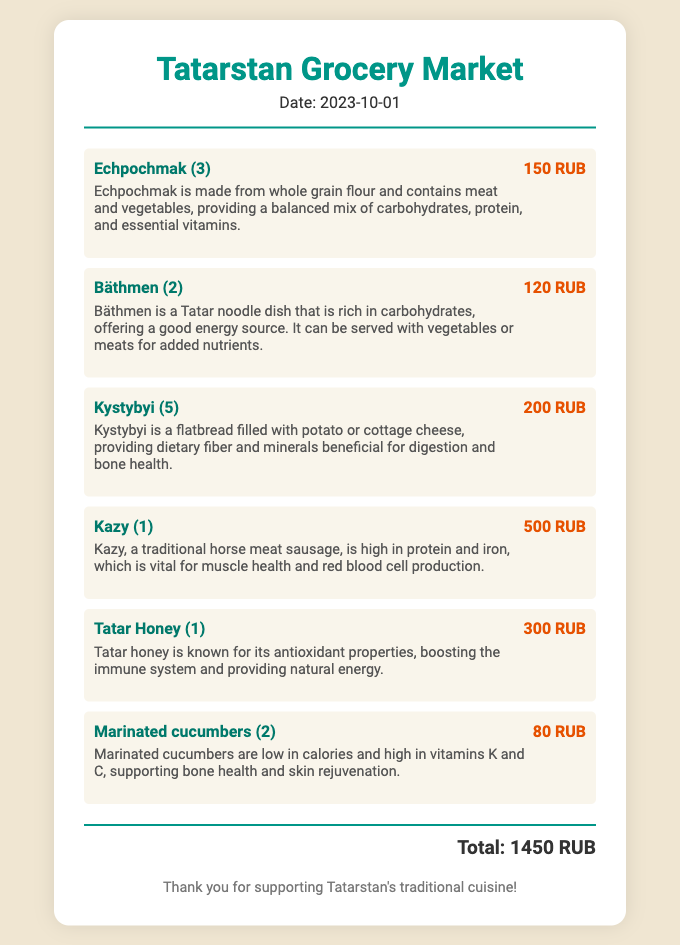What is the date on the receipt? The date is mentioned in the header section of the receipt, indicating when the transaction took place.
Answer: 2023-10-01 What is the total amount spent? The total amount is provided at the bottom of the receipt, summarizing the costs of all items purchased.
Answer: 1450 RUB How many Echpochmak were purchased? The number of Echpochmak is specified next to the item name, showing the quantity bought.
Answer: 3 What are the health benefits of Kazy? The health benefits are described alongside the item, highlighting the nutritional advantages of consuming it.
Answer: High in protein and iron How much do Marinated cucumbers cost? The price is listed next to the item and indicates how much was paid for them.
Answer: 80 RUB What is the total number of Kystybyi bought? The quantity bought is specified next to the item title in the receipt.
Answer: 5 Which item is noted for its antioxidant properties? The document provides health benefits for each item, mentioning which ones have specific properties.
Answer: Tatar Honey What is the main ingredient in Bäthmen? The document describes the item and mentions its primary nutrient, which is key to its dietary classification.
Answer: Carbohydrates What type of cuisine is promoted by this receipt? The receipt specifically promotes a unique cultural heritage, emphasizing the traditional foods of a particular region.
Answer: Tatarstan's traditional cuisine 